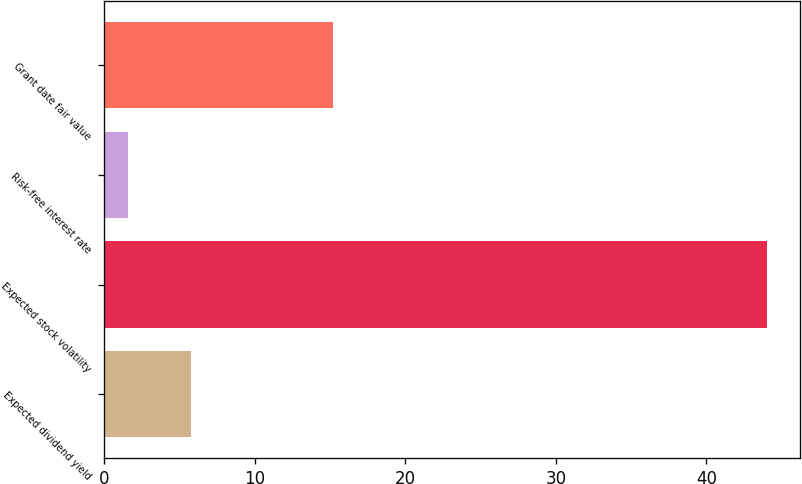<chart> <loc_0><loc_0><loc_500><loc_500><bar_chart><fcel>Expected dividend yield<fcel>Expected stock volatility<fcel>Risk-free interest rate<fcel>Grant date fair value<nl><fcel>5.79<fcel>44<fcel>1.55<fcel>15.19<nl></chart> 